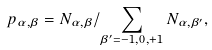<formula> <loc_0><loc_0><loc_500><loc_500>p _ { \alpha , \beta } = N _ { \alpha , \beta } / \sum _ { \beta ^ { \prime } = - 1 , 0 , + 1 } N _ { \alpha , \beta ^ { \prime } } ,</formula> 